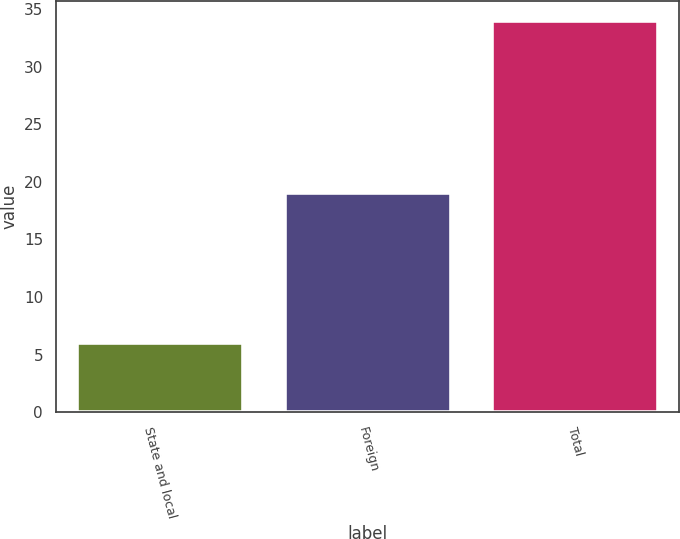<chart> <loc_0><loc_0><loc_500><loc_500><bar_chart><fcel>State and local<fcel>Foreign<fcel>Total<nl><fcel>6<fcel>19<fcel>34<nl></chart> 